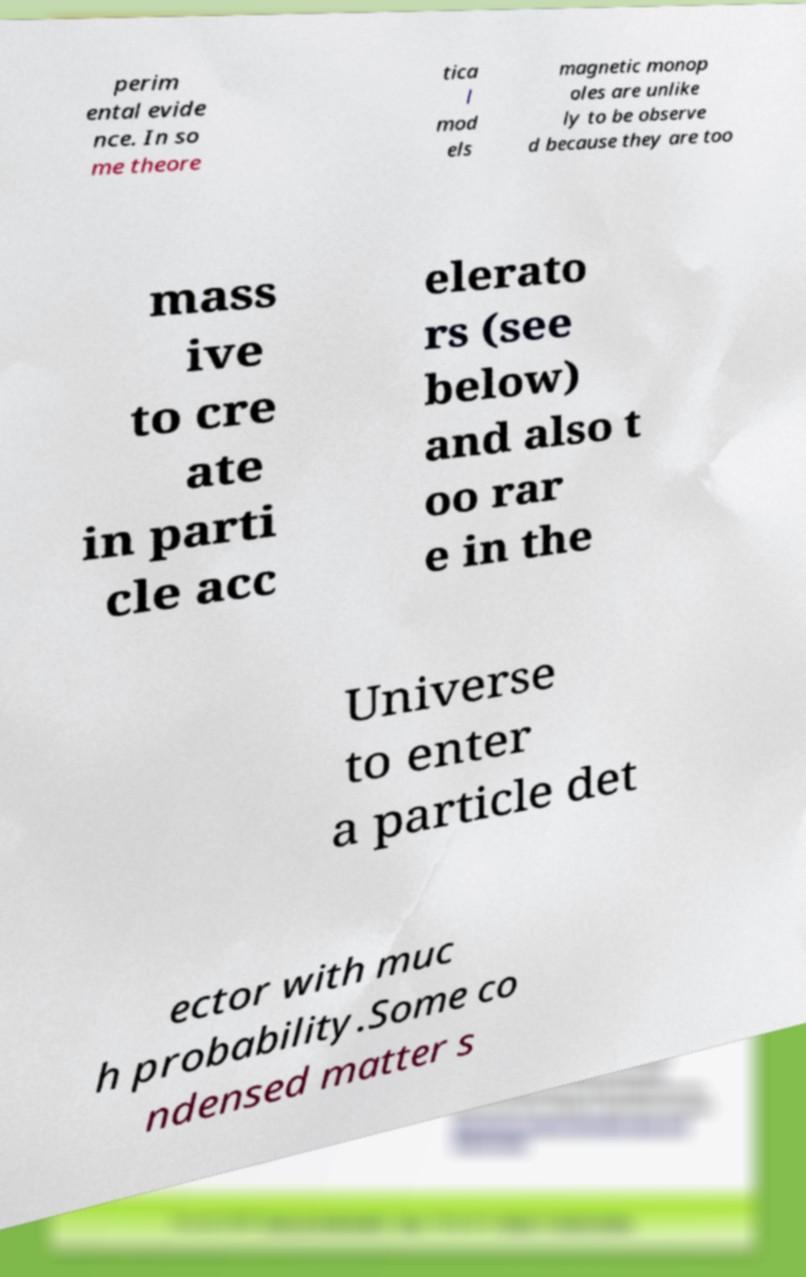Please identify and transcribe the text found in this image. perim ental evide nce. In so me theore tica l mod els magnetic monop oles are unlike ly to be observe d because they are too mass ive to cre ate in parti cle acc elerato rs (see below) and also t oo rar e in the Universe to enter a particle det ector with muc h probability.Some co ndensed matter s 